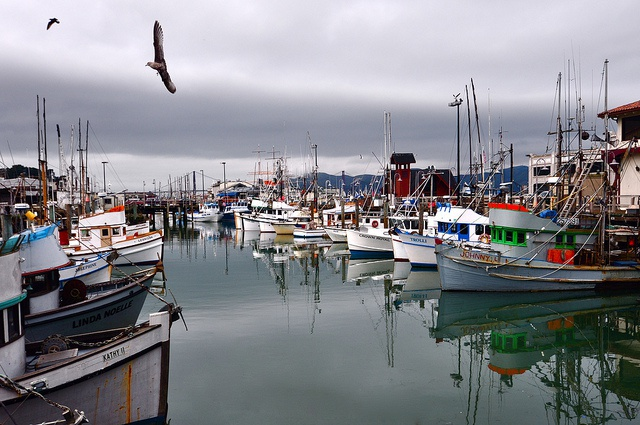Describe the objects in this image and their specific colors. I can see boat in lavender, darkgray, lightgray, black, and gray tones, boat in lavender, black, gray, darkgray, and maroon tones, boat in lavender, black, gray, darkgray, and blue tones, boat in lavender, black, darkgray, and gray tones, and boat in lavender, lightgray, darkgray, black, and gray tones in this image. 